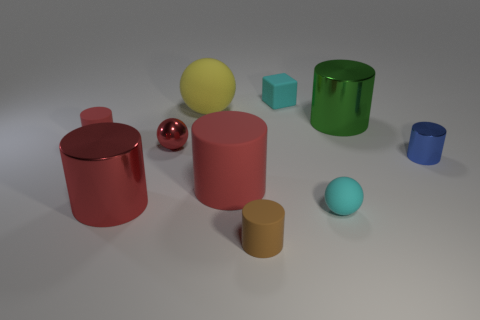Are there any cyan metallic cylinders? Yes, there is one cyan metallic cylinder in the image. It's located to the left of the center, partially behind a larger red cylinder. 